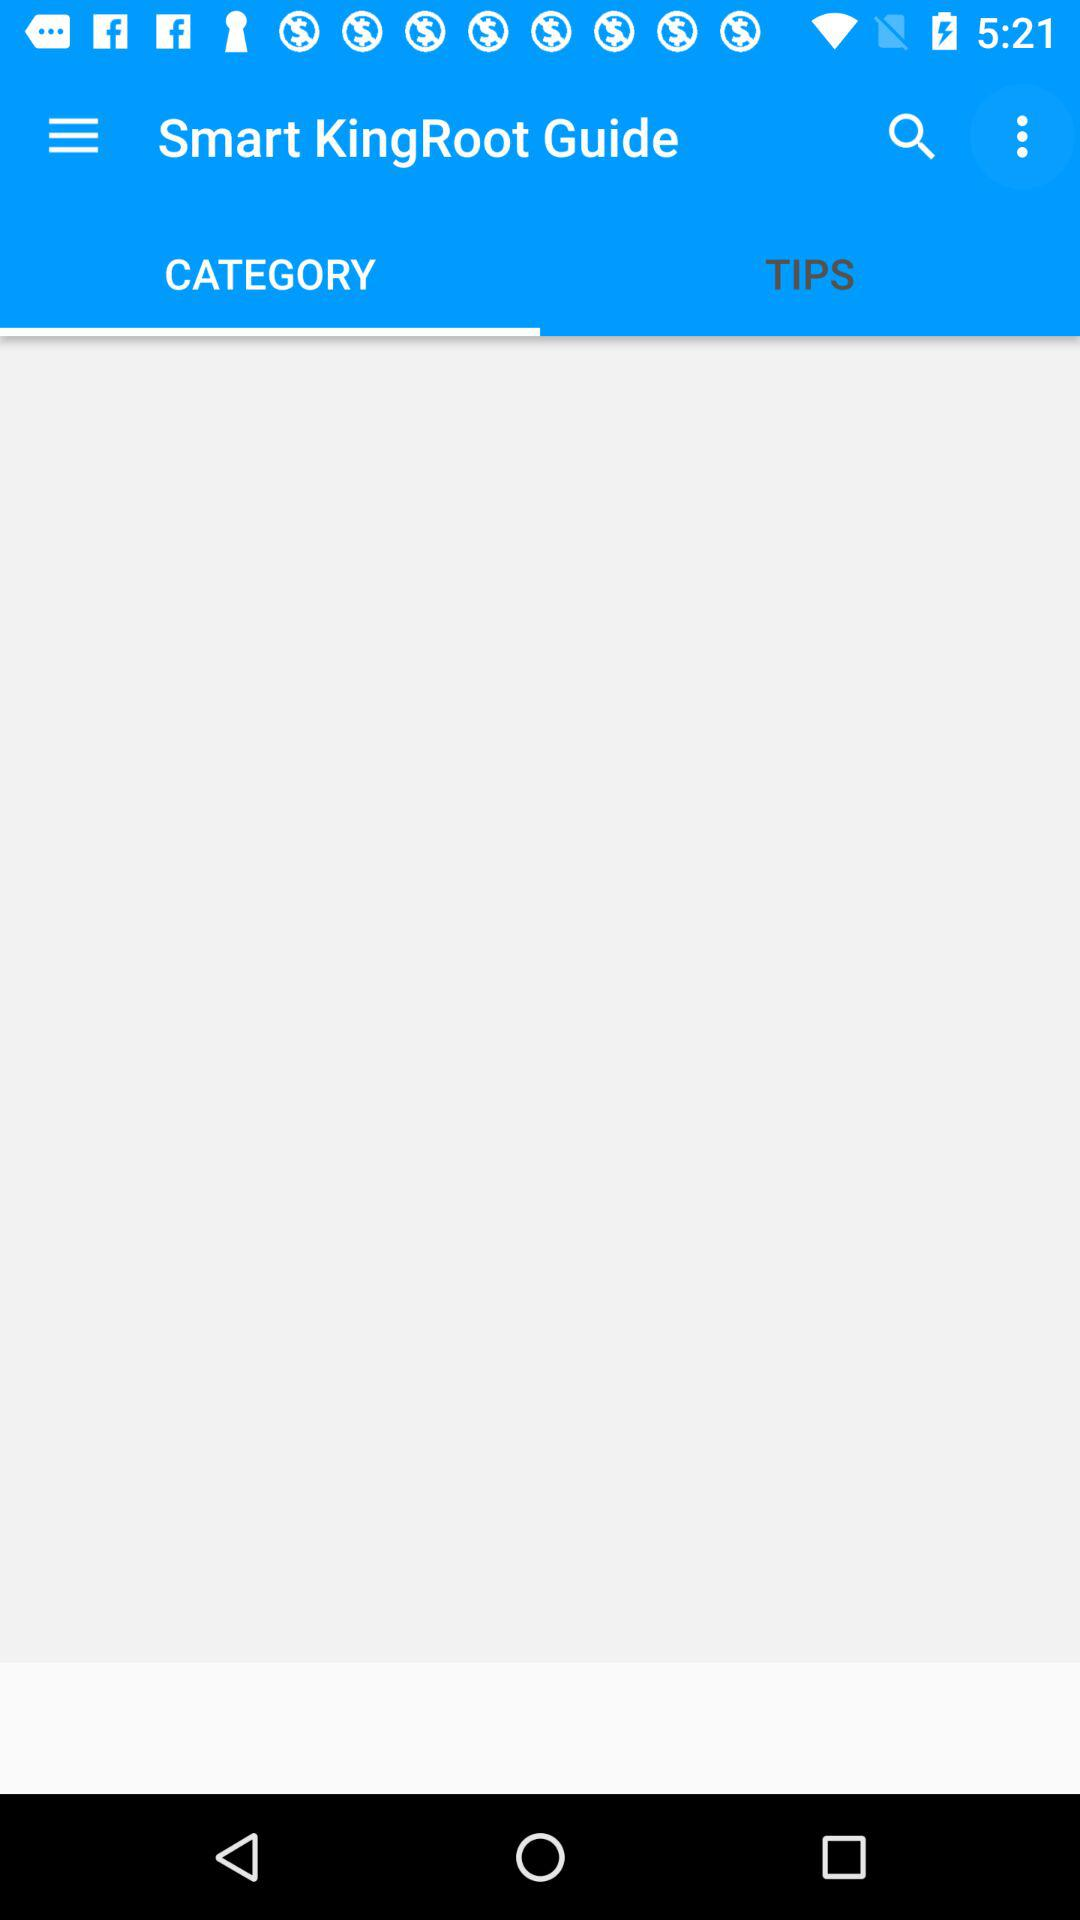Which tab is selected? The selected tab is "CATEGORY". 